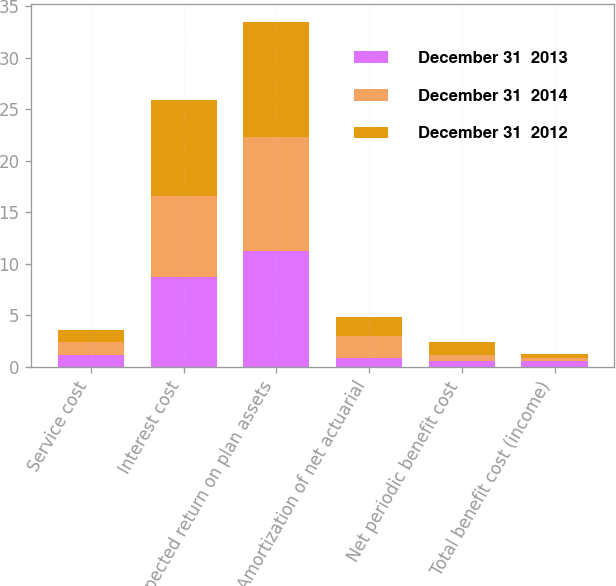Convert chart to OTSL. <chart><loc_0><loc_0><loc_500><loc_500><stacked_bar_chart><ecel><fcel>Service cost<fcel>Interest cost<fcel>Expected return on plan assets<fcel>Amortization of net actuarial<fcel>Net periodic benefit cost<fcel>Total benefit cost (income)<nl><fcel>December 31  2013<fcel>1.1<fcel>8.7<fcel>11.2<fcel>0.8<fcel>0.6<fcel>0.6<nl><fcel>December 31  2014<fcel>1.3<fcel>7.9<fcel>11.1<fcel>2.2<fcel>0.5<fcel>0.2<nl><fcel>December 31  2012<fcel>1.2<fcel>9.3<fcel>11.2<fcel>1.8<fcel>1.3<fcel>0.4<nl></chart> 